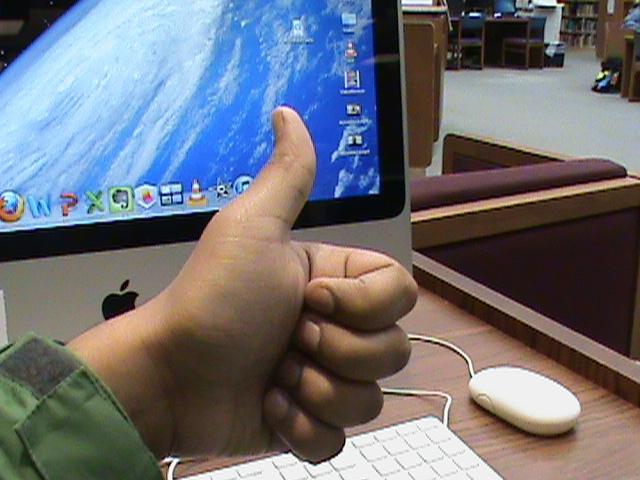Does this laptop run on Windows?
Quick response, please. No. Is the person typing on the keyboard?
Short answer required. No. Is the monitor on?
Quick response, please. Yes. Is the person playing a computer game?
Answer briefly. No. What color is the coil?
Be succinct. White. Is the person at the desk signifying positive or negative?
Short answer required. Positive. 